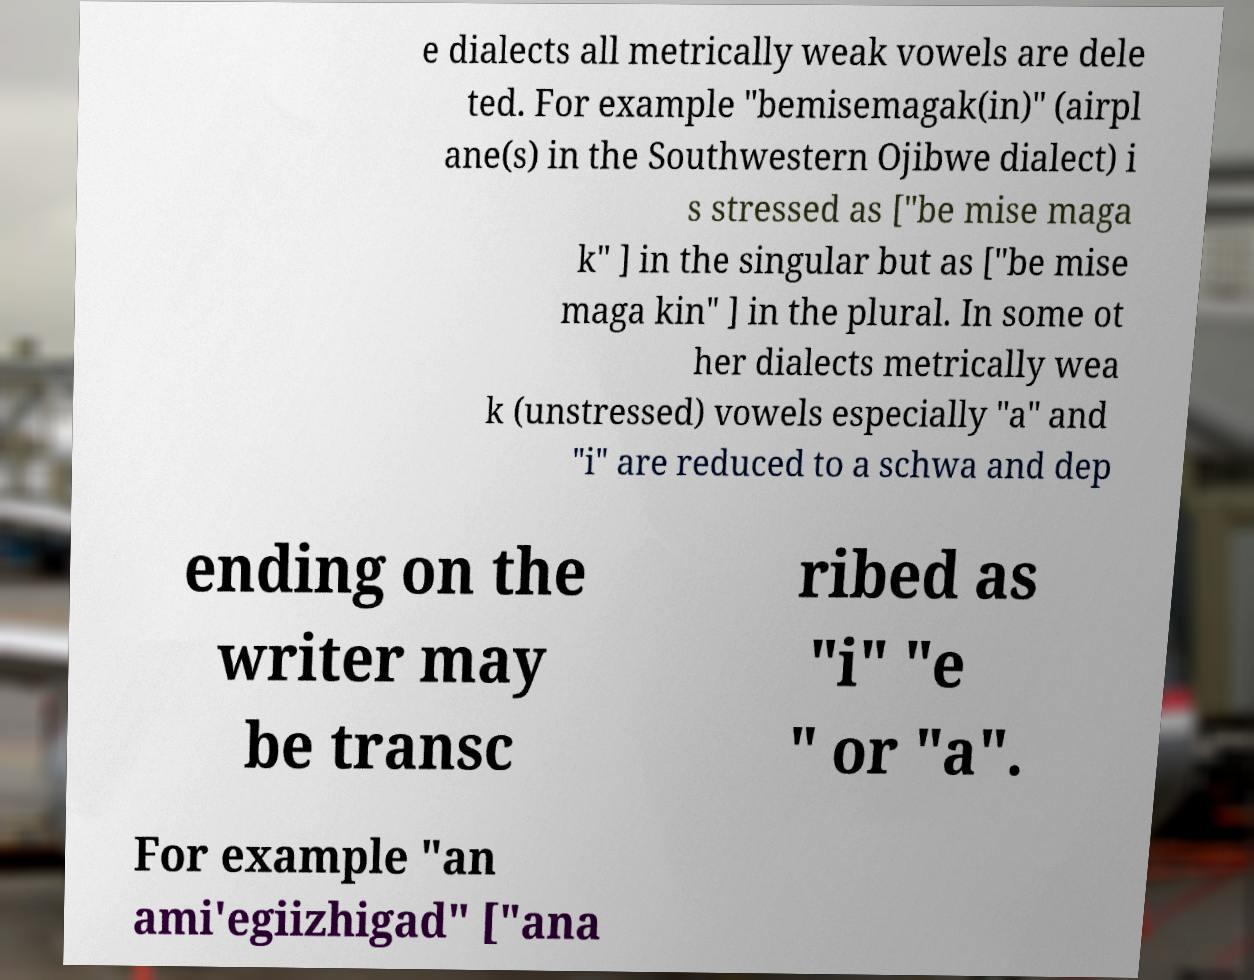Please identify and transcribe the text found in this image. e dialects all metrically weak vowels are dele ted. For example "bemisemagak(in)" (airpl ane(s) in the Southwestern Ojibwe dialect) i s stressed as ["be mise maga k" ] in the singular but as ["be mise maga kin" ] in the plural. In some ot her dialects metrically wea k (unstressed) vowels especially "a" and "i" are reduced to a schwa and dep ending on the writer may be transc ribed as "i" "e " or "a". For example "an ami'egiizhigad" ["ana 